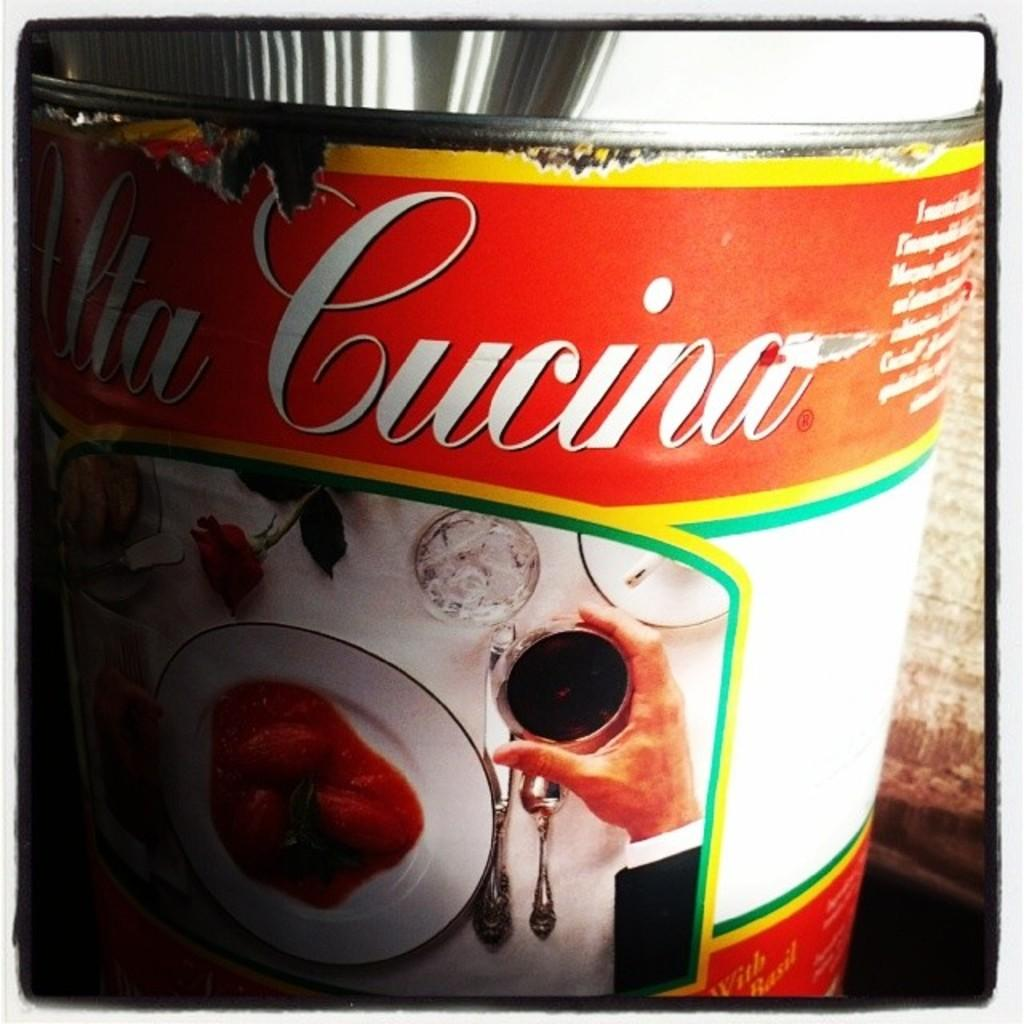<image>
Summarize the visual content of the image. The closeup of an open can of food has the word Cucina on it. 